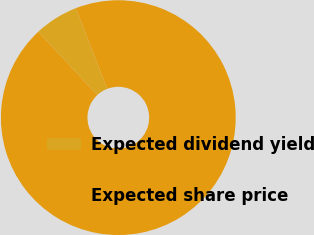Convert chart to OTSL. <chart><loc_0><loc_0><loc_500><loc_500><pie_chart><fcel>Expected dividend yield<fcel>Expected share price<nl><fcel>6.04%<fcel>93.96%<nl></chart> 